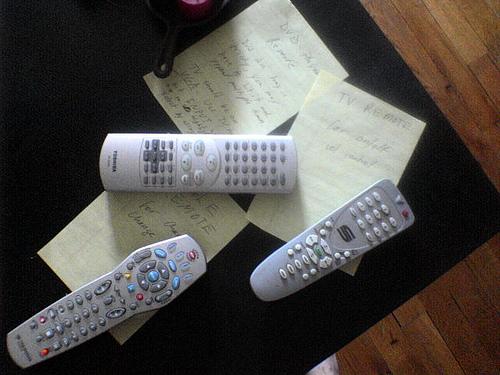Is there a pan in the photo?
Give a very brief answer. No. Are these different remote controls?
Write a very short answer. Yes. What color is the table?
Give a very brief answer. Black. 